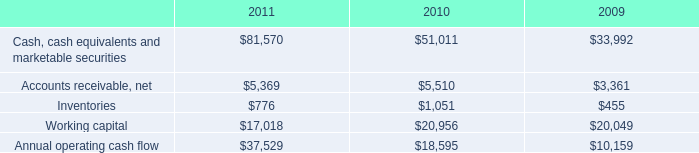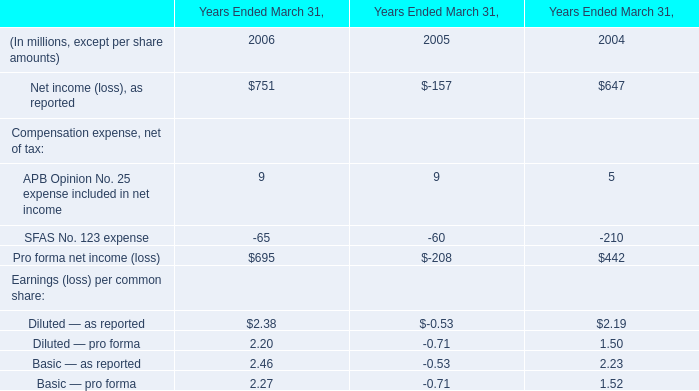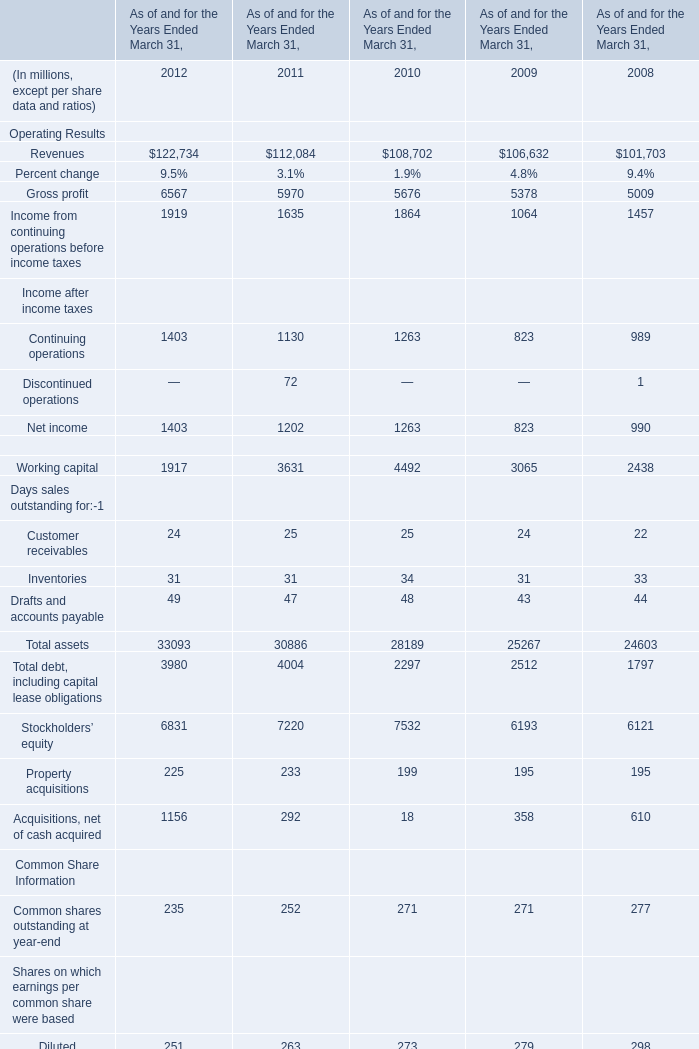what is the percentage change in annual operating cash flow from 2010 to 2011? 
Computations: ((37529 - 18595) / 18595)
Answer: 1.01823. 